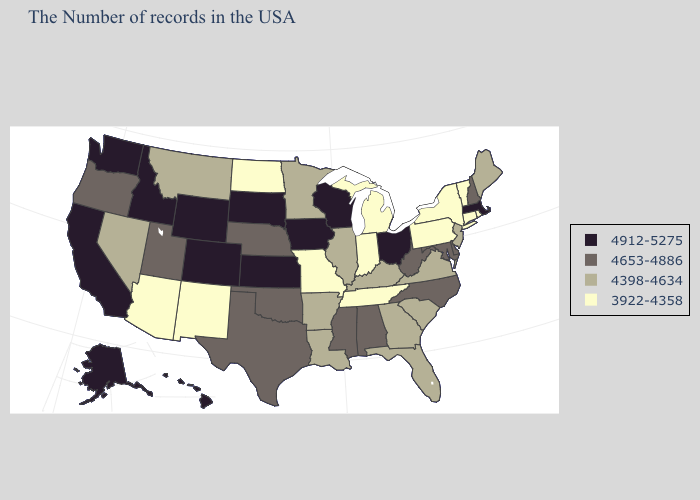Name the states that have a value in the range 4912-5275?
Concise answer only. Massachusetts, Ohio, Wisconsin, Iowa, Kansas, South Dakota, Wyoming, Colorado, Idaho, California, Washington, Alaska, Hawaii. Does the first symbol in the legend represent the smallest category?
Be succinct. No. Among the states that border Connecticut , which have the highest value?
Be succinct. Massachusetts. Name the states that have a value in the range 4653-4886?
Short answer required. New Hampshire, Delaware, Maryland, North Carolina, West Virginia, Alabama, Mississippi, Nebraska, Oklahoma, Texas, Utah, Oregon. Name the states that have a value in the range 3922-4358?
Short answer required. Rhode Island, Vermont, Connecticut, New York, Pennsylvania, Michigan, Indiana, Tennessee, Missouri, North Dakota, New Mexico, Arizona. Name the states that have a value in the range 4912-5275?
Answer briefly. Massachusetts, Ohio, Wisconsin, Iowa, Kansas, South Dakota, Wyoming, Colorado, Idaho, California, Washington, Alaska, Hawaii. Among the states that border Montana , does North Dakota have the lowest value?
Write a very short answer. Yes. Does Nebraska have a higher value than New Mexico?
Be succinct. Yes. Which states have the lowest value in the USA?
Be succinct. Rhode Island, Vermont, Connecticut, New York, Pennsylvania, Michigan, Indiana, Tennessee, Missouri, North Dakota, New Mexico, Arizona. Among the states that border North Carolina , which have the lowest value?
Concise answer only. Tennessee. Name the states that have a value in the range 4653-4886?
Quick response, please. New Hampshire, Delaware, Maryland, North Carolina, West Virginia, Alabama, Mississippi, Nebraska, Oklahoma, Texas, Utah, Oregon. Does Arizona have the same value as Connecticut?
Give a very brief answer. Yes. What is the value of Indiana?
Write a very short answer. 3922-4358. What is the highest value in the USA?
Quick response, please. 4912-5275. Name the states that have a value in the range 4653-4886?
Answer briefly. New Hampshire, Delaware, Maryland, North Carolina, West Virginia, Alabama, Mississippi, Nebraska, Oklahoma, Texas, Utah, Oregon. 